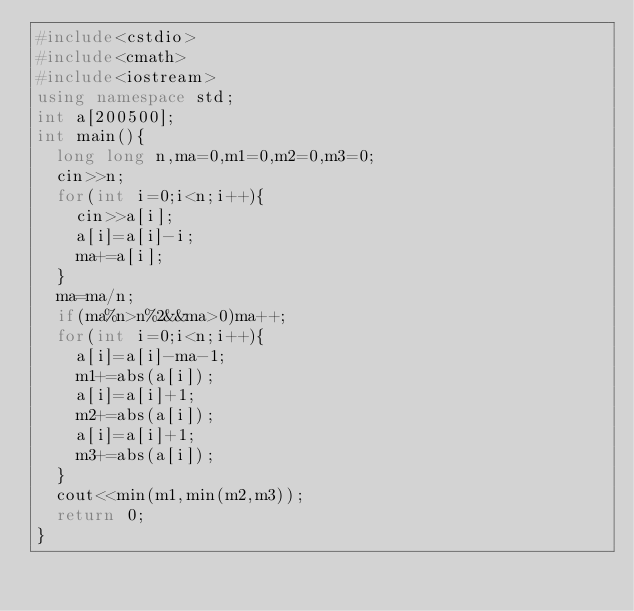Convert code to text. <code><loc_0><loc_0><loc_500><loc_500><_C++_>#include<cstdio>
#include<cmath>
#include<iostream>
using namespace std;
int a[200500];
int main(){
	long long n,ma=0,m1=0,m2=0,m3=0;
	cin>>n;
	for(int i=0;i<n;i++){
		cin>>a[i];
		a[i]=a[i]-i;
		ma+=a[i];
	}
	ma=ma/n;
	if(ma%n>n%2&&ma>0)ma++;
	for(int i=0;i<n;i++){
		a[i]=a[i]-ma-1;
		m1+=abs(a[i]);
		a[i]=a[i]+1;
		m2+=abs(a[i]);
		a[i]=a[i]+1;
		m3+=abs(a[i]);
	}
	cout<<min(m1,min(m2,m3));
	return 0;
}</code> 